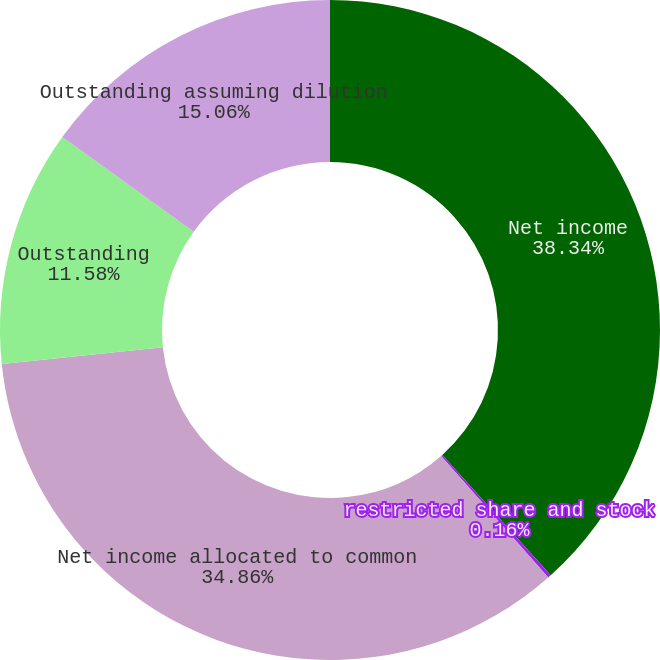Convert chart. <chart><loc_0><loc_0><loc_500><loc_500><pie_chart><fcel>Net income<fcel>restricted share and stock<fcel>Net income allocated to common<fcel>Outstanding<fcel>Outstanding assuming dilution<nl><fcel>38.34%<fcel>0.16%<fcel>34.86%<fcel>11.58%<fcel>15.06%<nl></chart> 